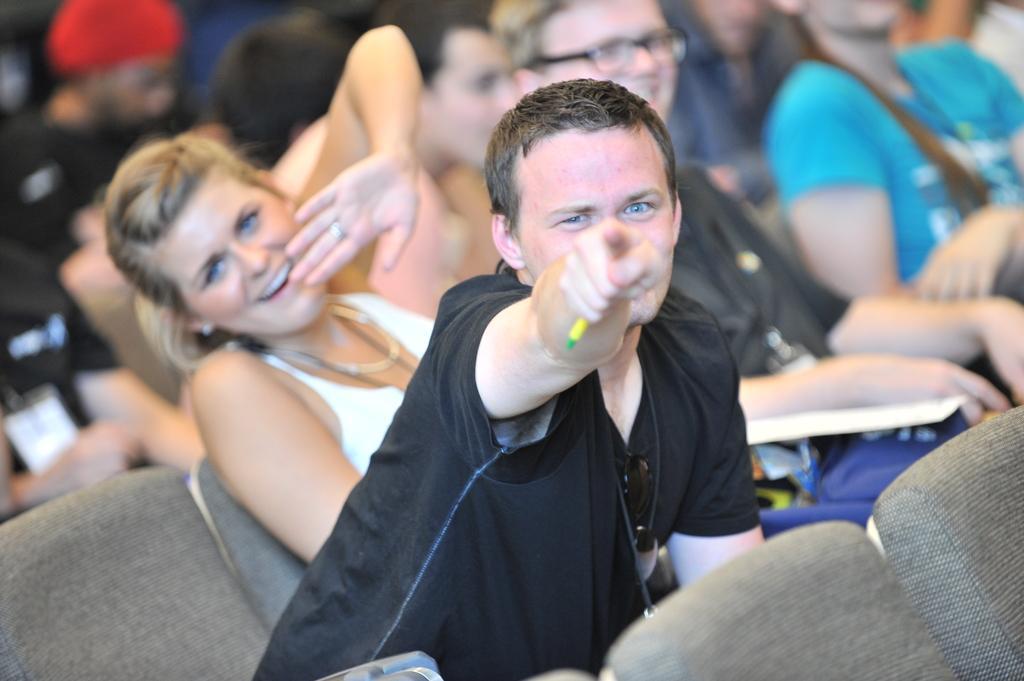How would you summarize this image in a sentence or two? In this picture we can see some people sitting on chairs, a person in the front is pointing his finger towards something. 